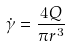Convert formula to latex. <formula><loc_0><loc_0><loc_500><loc_500>\dot { \gamma } = \frac { 4 Q } { \pi r ^ { 3 } }</formula> 